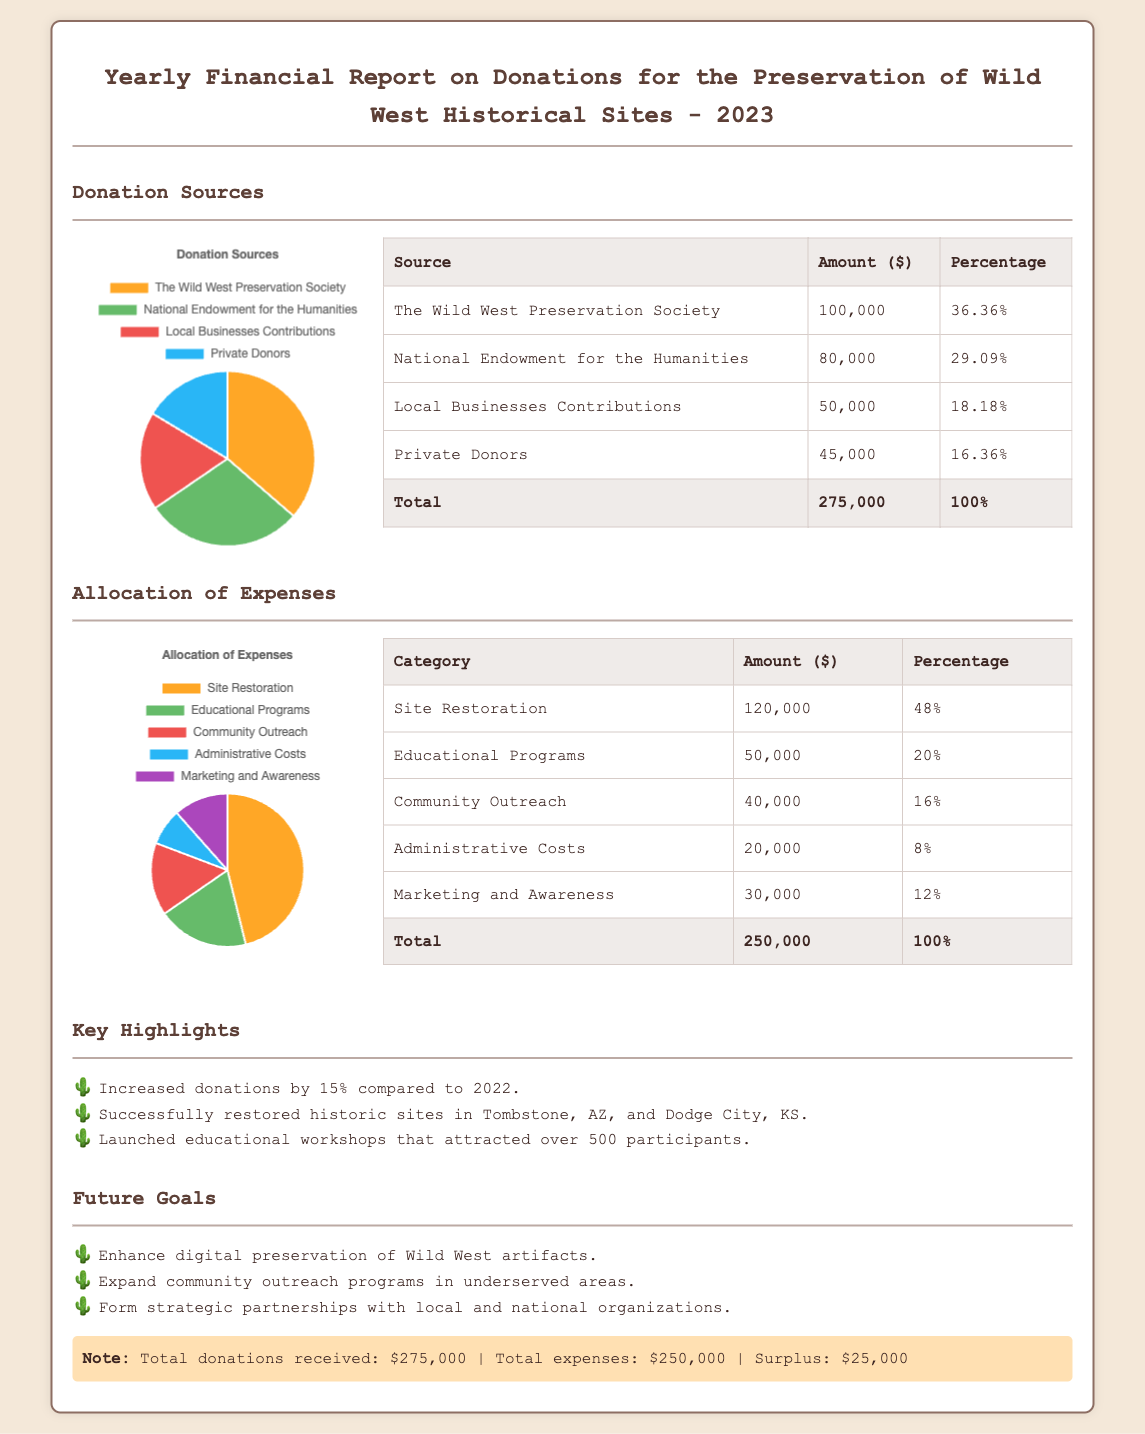What was the total amount of donations received? The total amount of donations is stated clearly in the document, which is $275,000.
Answer: $275,000 What percentage of donations came from private donors? The document lists private donors contributing $45,000, which accounts for 16.36% of the total donations.
Answer: 16.36% How much was allocated for site restoration? The expense allocation for site restoration is specifically mentioned as $120,000.
Answer: $120,000 What was the increase in donations compared to 2022? The document highlights that donations increased by 15% compared to the previous year.
Answer: 15% What is the surplus after expenses are accounted for? The report indicates a surplus of $25,000 after total donations and expenses are considered.
Answer: $25,000 Which source contributed the most to the donations? The document lists The Wild West Preservation Society as the largest contributor with $100,000.
Answer: The Wild West Preservation Society What percentage of the total expenses is spent on educational programs? It states that expenses for educational programs account for 20% of the total expenses.
Answer: 20% How much was spent on marketing and awareness? The document specifies that $30,000 was allocated to marketing and awareness.
Answer: $30,000 What is one of the future goals mentioned in the report? The document states that enhancing digital preservation of Wild West artifacts is a future goal.
Answer: Enhance digital preservation of Wild West artifacts 